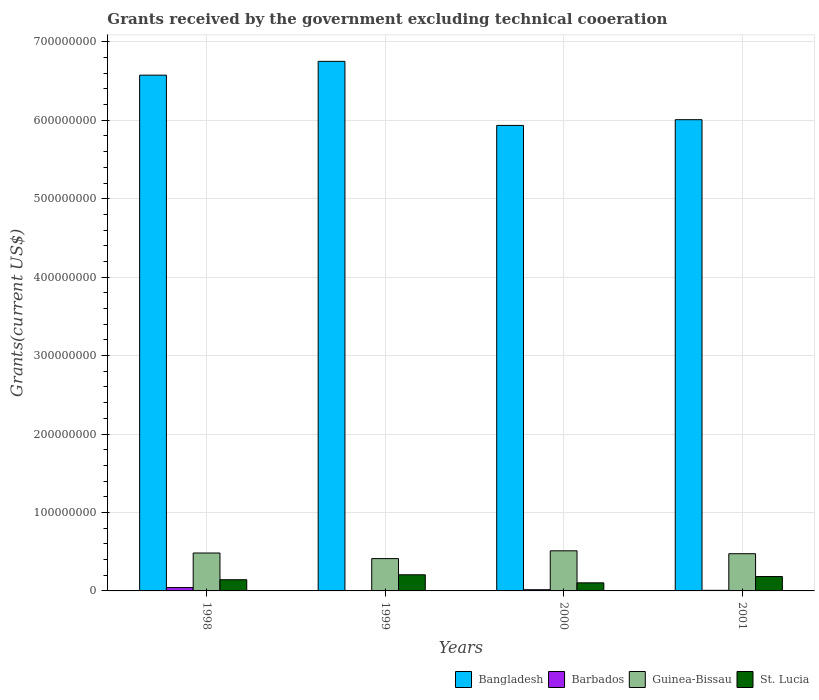How many different coloured bars are there?
Your answer should be compact. 4. Are the number of bars per tick equal to the number of legend labels?
Make the answer very short. Yes. Are the number of bars on each tick of the X-axis equal?
Your answer should be very brief. Yes. In how many cases, is the number of bars for a given year not equal to the number of legend labels?
Offer a very short reply. 0. What is the total grants received by the government in St. Lucia in 2001?
Keep it short and to the point. 1.83e+07. Across all years, what is the maximum total grants received by the government in Bangladesh?
Offer a very short reply. 6.75e+08. Across all years, what is the minimum total grants received by the government in Guinea-Bissau?
Provide a succinct answer. 4.12e+07. What is the total total grants received by the government in Barbados in the graph?
Offer a terse response. 6.74e+06. What is the difference between the total grants received by the government in Bangladesh in 1998 and that in 1999?
Keep it short and to the point. -1.76e+07. What is the difference between the total grants received by the government in Guinea-Bissau in 2000 and the total grants received by the government in Bangladesh in 1998?
Provide a succinct answer. -6.06e+08. What is the average total grants received by the government in St. Lucia per year?
Make the answer very short. 1.59e+07. In the year 2001, what is the difference between the total grants received by the government in St. Lucia and total grants received by the government in Barbados?
Your answer should be very brief. 1.76e+07. What is the ratio of the total grants received by the government in Bangladesh in 2000 to that in 2001?
Your answer should be very brief. 0.99. Is the total grants received by the government in St. Lucia in 2000 less than that in 2001?
Make the answer very short. Yes. Is the difference between the total grants received by the government in St. Lucia in 1998 and 2000 greater than the difference between the total grants received by the government in Barbados in 1998 and 2000?
Provide a succinct answer. Yes. What is the difference between the highest and the second highest total grants received by the government in St. Lucia?
Provide a short and direct response. 2.22e+06. What is the difference between the highest and the lowest total grants received by the government in Bangladesh?
Ensure brevity in your answer.  8.17e+07. In how many years, is the total grants received by the government in St. Lucia greater than the average total grants received by the government in St. Lucia taken over all years?
Your response must be concise. 2. Is the sum of the total grants received by the government in Bangladesh in 1999 and 2001 greater than the maximum total grants received by the government in Barbados across all years?
Your response must be concise. Yes. What does the 3rd bar from the left in 2001 represents?
Keep it short and to the point. Guinea-Bissau. What does the 2nd bar from the right in 2000 represents?
Offer a very short reply. Guinea-Bissau. Are the values on the major ticks of Y-axis written in scientific E-notation?
Provide a short and direct response. No. Does the graph contain grids?
Give a very brief answer. Yes. Where does the legend appear in the graph?
Make the answer very short. Bottom right. How many legend labels are there?
Your answer should be compact. 4. How are the legend labels stacked?
Provide a short and direct response. Horizontal. What is the title of the graph?
Ensure brevity in your answer.  Grants received by the government excluding technical cooeration. Does "Myanmar" appear as one of the legend labels in the graph?
Keep it short and to the point. No. What is the label or title of the Y-axis?
Your answer should be compact. Grants(current US$). What is the Grants(current US$) of Bangladesh in 1998?
Offer a very short reply. 6.58e+08. What is the Grants(current US$) in Barbados in 1998?
Ensure brevity in your answer.  4.30e+06. What is the Grants(current US$) of Guinea-Bissau in 1998?
Keep it short and to the point. 4.83e+07. What is the Grants(current US$) of St. Lucia in 1998?
Offer a very short reply. 1.43e+07. What is the Grants(current US$) of Bangladesh in 1999?
Keep it short and to the point. 6.75e+08. What is the Grants(current US$) of Barbados in 1999?
Your response must be concise. 1.70e+05. What is the Grants(current US$) of Guinea-Bissau in 1999?
Keep it short and to the point. 4.12e+07. What is the Grants(current US$) of St. Lucia in 1999?
Give a very brief answer. 2.06e+07. What is the Grants(current US$) in Bangladesh in 2000?
Ensure brevity in your answer.  5.93e+08. What is the Grants(current US$) in Barbados in 2000?
Offer a terse response. 1.53e+06. What is the Grants(current US$) of Guinea-Bissau in 2000?
Keep it short and to the point. 5.12e+07. What is the Grants(current US$) of St. Lucia in 2000?
Give a very brief answer. 1.03e+07. What is the Grants(current US$) of Bangladesh in 2001?
Provide a succinct answer. 6.01e+08. What is the Grants(current US$) in Barbados in 2001?
Ensure brevity in your answer.  7.40e+05. What is the Grants(current US$) of Guinea-Bissau in 2001?
Give a very brief answer. 4.74e+07. What is the Grants(current US$) in St. Lucia in 2001?
Give a very brief answer. 1.83e+07. Across all years, what is the maximum Grants(current US$) in Bangladesh?
Your answer should be very brief. 6.75e+08. Across all years, what is the maximum Grants(current US$) in Barbados?
Your answer should be very brief. 4.30e+06. Across all years, what is the maximum Grants(current US$) in Guinea-Bissau?
Give a very brief answer. 5.12e+07. Across all years, what is the maximum Grants(current US$) in St. Lucia?
Your response must be concise. 2.06e+07. Across all years, what is the minimum Grants(current US$) of Bangladesh?
Your answer should be very brief. 5.93e+08. Across all years, what is the minimum Grants(current US$) of Barbados?
Your response must be concise. 1.70e+05. Across all years, what is the minimum Grants(current US$) of Guinea-Bissau?
Your answer should be compact. 4.12e+07. Across all years, what is the minimum Grants(current US$) in St. Lucia?
Offer a terse response. 1.03e+07. What is the total Grants(current US$) in Bangladesh in the graph?
Your answer should be very brief. 2.53e+09. What is the total Grants(current US$) in Barbados in the graph?
Your response must be concise. 6.74e+06. What is the total Grants(current US$) in Guinea-Bissau in the graph?
Give a very brief answer. 1.88e+08. What is the total Grants(current US$) of St. Lucia in the graph?
Your answer should be very brief. 6.35e+07. What is the difference between the Grants(current US$) of Bangladesh in 1998 and that in 1999?
Make the answer very short. -1.76e+07. What is the difference between the Grants(current US$) of Barbados in 1998 and that in 1999?
Provide a succinct answer. 4.13e+06. What is the difference between the Grants(current US$) of Guinea-Bissau in 1998 and that in 1999?
Your answer should be very brief. 7.12e+06. What is the difference between the Grants(current US$) in St. Lucia in 1998 and that in 1999?
Provide a succinct answer. -6.30e+06. What is the difference between the Grants(current US$) of Bangladesh in 1998 and that in 2000?
Give a very brief answer. 6.41e+07. What is the difference between the Grants(current US$) in Barbados in 1998 and that in 2000?
Ensure brevity in your answer.  2.77e+06. What is the difference between the Grants(current US$) in Guinea-Bissau in 1998 and that in 2000?
Your answer should be compact. -2.82e+06. What is the difference between the Grants(current US$) in St. Lucia in 1998 and that in 2000?
Your answer should be compact. 3.96e+06. What is the difference between the Grants(current US$) in Bangladesh in 1998 and that in 2001?
Keep it short and to the point. 5.68e+07. What is the difference between the Grants(current US$) of Barbados in 1998 and that in 2001?
Offer a terse response. 3.56e+06. What is the difference between the Grants(current US$) of Guinea-Bissau in 1998 and that in 2001?
Provide a succinct answer. 8.90e+05. What is the difference between the Grants(current US$) in St. Lucia in 1998 and that in 2001?
Your response must be concise. -4.08e+06. What is the difference between the Grants(current US$) in Bangladesh in 1999 and that in 2000?
Give a very brief answer. 8.17e+07. What is the difference between the Grants(current US$) of Barbados in 1999 and that in 2000?
Give a very brief answer. -1.36e+06. What is the difference between the Grants(current US$) of Guinea-Bissau in 1999 and that in 2000?
Your response must be concise. -9.94e+06. What is the difference between the Grants(current US$) in St. Lucia in 1999 and that in 2000?
Offer a very short reply. 1.03e+07. What is the difference between the Grants(current US$) in Bangladesh in 1999 and that in 2001?
Your response must be concise. 7.44e+07. What is the difference between the Grants(current US$) in Barbados in 1999 and that in 2001?
Make the answer very short. -5.70e+05. What is the difference between the Grants(current US$) of Guinea-Bissau in 1999 and that in 2001?
Offer a terse response. -6.23e+06. What is the difference between the Grants(current US$) of St. Lucia in 1999 and that in 2001?
Offer a terse response. 2.22e+06. What is the difference between the Grants(current US$) of Bangladesh in 2000 and that in 2001?
Make the answer very short. -7.28e+06. What is the difference between the Grants(current US$) in Barbados in 2000 and that in 2001?
Your response must be concise. 7.90e+05. What is the difference between the Grants(current US$) of Guinea-Bissau in 2000 and that in 2001?
Your answer should be very brief. 3.71e+06. What is the difference between the Grants(current US$) of St. Lucia in 2000 and that in 2001?
Keep it short and to the point. -8.04e+06. What is the difference between the Grants(current US$) in Bangladesh in 1998 and the Grants(current US$) in Barbados in 1999?
Ensure brevity in your answer.  6.57e+08. What is the difference between the Grants(current US$) in Bangladesh in 1998 and the Grants(current US$) in Guinea-Bissau in 1999?
Keep it short and to the point. 6.16e+08. What is the difference between the Grants(current US$) in Bangladesh in 1998 and the Grants(current US$) in St. Lucia in 1999?
Provide a succinct answer. 6.37e+08. What is the difference between the Grants(current US$) of Barbados in 1998 and the Grants(current US$) of Guinea-Bissau in 1999?
Provide a succinct answer. -3.69e+07. What is the difference between the Grants(current US$) of Barbados in 1998 and the Grants(current US$) of St. Lucia in 1999?
Make the answer very short. -1.63e+07. What is the difference between the Grants(current US$) in Guinea-Bissau in 1998 and the Grants(current US$) in St. Lucia in 1999?
Keep it short and to the point. 2.78e+07. What is the difference between the Grants(current US$) of Bangladesh in 1998 and the Grants(current US$) of Barbados in 2000?
Your answer should be very brief. 6.56e+08. What is the difference between the Grants(current US$) of Bangladesh in 1998 and the Grants(current US$) of Guinea-Bissau in 2000?
Provide a succinct answer. 6.06e+08. What is the difference between the Grants(current US$) of Bangladesh in 1998 and the Grants(current US$) of St. Lucia in 2000?
Keep it short and to the point. 6.47e+08. What is the difference between the Grants(current US$) in Barbados in 1998 and the Grants(current US$) in Guinea-Bissau in 2000?
Offer a terse response. -4.68e+07. What is the difference between the Grants(current US$) in Barbados in 1998 and the Grants(current US$) in St. Lucia in 2000?
Your answer should be compact. -6.00e+06. What is the difference between the Grants(current US$) in Guinea-Bissau in 1998 and the Grants(current US$) in St. Lucia in 2000?
Your answer should be compact. 3.80e+07. What is the difference between the Grants(current US$) of Bangladesh in 1998 and the Grants(current US$) of Barbados in 2001?
Provide a succinct answer. 6.57e+08. What is the difference between the Grants(current US$) of Bangladesh in 1998 and the Grants(current US$) of Guinea-Bissau in 2001?
Offer a terse response. 6.10e+08. What is the difference between the Grants(current US$) of Bangladesh in 1998 and the Grants(current US$) of St. Lucia in 2001?
Make the answer very short. 6.39e+08. What is the difference between the Grants(current US$) in Barbados in 1998 and the Grants(current US$) in Guinea-Bissau in 2001?
Keep it short and to the point. -4.31e+07. What is the difference between the Grants(current US$) of Barbados in 1998 and the Grants(current US$) of St. Lucia in 2001?
Provide a short and direct response. -1.40e+07. What is the difference between the Grants(current US$) of Guinea-Bissau in 1998 and the Grants(current US$) of St. Lucia in 2001?
Your answer should be very brief. 3.00e+07. What is the difference between the Grants(current US$) in Bangladesh in 1999 and the Grants(current US$) in Barbados in 2000?
Offer a terse response. 6.74e+08. What is the difference between the Grants(current US$) in Bangladesh in 1999 and the Grants(current US$) in Guinea-Bissau in 2000?
Offer a very short reply. 6.24e+08. What is the difference between the Grants(current US$) of Bangladesh in 1999 and the Grants(current US$) of St. Lucia in 2000?
Offer a very short reply. 6.65e+08. What is the difference between the Grants(current US$) in Barbados in 1999 and the Grants(current US$) in Guinea-Bissau in 2000?
Your answer should be compact. -5.10e+07. What is the difference between the Grants(current US$) of Barbados in 1999 and the Grants(current US$) of St. Lucia in 2000?
Your answer should be compact. -1.01e+07. What is the difference between the Grants(current US$) in Guinea-Bissau in 1999 and the Grants(current US$) in St. Lucia in 2000?
Offer a terse response. 3.09e+07. What is the difference between the Grants(current US$) of Bangladesh in 1999 and the Grants(current US$) of Barbados in 2001?
Offer a very short reply. 6.74e+08. What is the difference between the Grants(current US$) in Bangladesh in 1999 and the Grants(current US$) in Guinea-Bissau in 2001?
Your response must be concise. 6.28e+08. What is the difference between the Grants(current US$) of Bangladesh in 1999 and the Grants(current US$) of St. Lucia in 2001?
Make the answer very short. 6.57e+08. What is the difference between the Grants(current US$) in Barbados in 1999 and the Grants(current US$) in Guinea-Bissau in 2001?
Ensure brevity in your answer.  -4.73e+07. What is the difference between the Grants(current US$) in Barbados in 1999 and the Grants(current US$) in St. Lucia in 2001?
Your answer should be very brief. -1.82e+07. What is the difference between the Grants(current US$) of Guinea-Bissau in 1999 and the Grants(current US$) of St. Lucia in 2001?
Ensure brevity in your answer.  2.29e+07. What is the difference between the Grants(current US$) in Bangladesh in 2000 and the Grants(current US$) in Barbados in 2001?
Offer a very short reply. 5.93e+08. What is the difference between the Grants(current US$) of Bangladesh in 2000 and the Grants(current US$) of Guinea-Bissau in 2001?
Provide a short and direct response. 5.46e+08. What is the difference between the Grants(current US$) of Bangladesh in 2000 and the Grants(current US$) of St. Lucia in 2001?
Offer a terse response. 5.75e+08. What is the difference between the Grants(current US$) of Barbados in 2000 and the Grants(current US$) of Guinea-Bissau in 2001?
Your response must be concise. -4.59e+07. What is the difference between the Grants(current US$) in Barbados in 2000 and the Grants(current US$) in St. Lucia in 2001?
Your answer should be compact. -1.68e+07. What is the difference between the Grants(current US$) in Guinea-Bissau in 2000 and the Grants(current US$) in St. Lucia in 2001?
Keep it short and to the point. 3.28e+07. What is the average Grants(current US$) in Bangladesh per year?
Provide a short and direct response. 6.32e+08. What is the average Grants(current US$) in Barbados per year?
Offer a terse response. 1.68e+06. What is the average Grants(current US$) of Guinea-Bissau per year?
Make the answer very short. 4.70e+07. What is the average Grants(current US$) of St. Lucia per year?
Give a very brief answer. 1.59e+07. In the year 1998, what is the difference between the Grants(current US$) of Bangladesh and Grants(current US$) of Barbados?
Your answer should be compact. 6.53e+08. In the year 1998, what is the difference between the Grants(current US$) of Bangladesh and Grants(current US$) of Guinea-Bissau?
Offer a very short reply. 6.09e+08. In the year 1998, what is the difference between the Grants(current US$) of Bangladesh and Grants(current US$) of St. Lucia?
Your answer should be compact. 6.43e+08. In the year 1998, what is the difference between the Grants(current US$) in Barbados and Grants(current US$) in Guinea-Bissau?
Make the answer very short. -4.40e+07. In the year 1998, what is the difference between the Grants(current US$) of Barbados and Grants(current US$) of St. Lucia?
Your response must be concise. -9.96e+06. In the year 1998, what is the difference between the Grants(current US$) of Guinea-Bissau and Grants(current US$) of St. Lucia?
Make the answer very short. 3.41e+07. In the year 1999, what is the difference between the Grants(current US$) of Bangladesh and Grants(current US$) of Barbados?
Offer a very short reply. 6.75e+08. In the year 1999, what is the difference between the Grants(current US$) in Bangladesh and Grants(current US$) in Guinea-Bissau?
Make the answer very short. 6.34e+08. In the year 1999, what is the difference between the Grants(current US$) in Bangladesh and Grants(current US$) in St. Lucia?
Your answer should be very brief. 6.55e+08. In the year 1999, what is the difference between the Grants(current US$) of Barbados and Grants(current US$) of Guinea-Bissau?
Provide a short and direct response. -4.10e+07. In the year 1999, what is the difference between the Grants(current US$) in Barbados and Grants(current US$) in St. Lucia?
Give a very brief answer. -2.04e+07. In the year 1999, what is the difference between the Grants(current US$) in Guinea-Bissau and Grants(current US$) in St. Lucia?
Ensure brevity in your answer.  2.06e+07. In the year 2000, what is the difference between the Grants(current US$) in Bangladesh and Grants(current US$) in Barbados?
Provide a short and direct response. 5.92e+08. In the year 2000, what is the difference between the Grants(current US$) in Bangladesh and Grants(current US$) in Guinea-Bissau?
Your answer should be very brief. 5.42e+08. In the year 2000, what is the difference between the Grants(current US$) in Bangladesh and Grants(current US$) in St. Lucia?
Your answer should be very brief. 5.83e+08. In the year 2000, what is the difference between the Grants(current US$) in Barbados and Grants(current US$) in Guinea-Bissau?
Ensure brevity in your answer.  -4.96e+07. In the year 2000, what is the difference between the Grants(current US$) in Barbados and Grants(current US$) in St. Lucia?
Ensure brevity in your answer.  -8.77e+06. In the year 2000, what is the difference between the Grants(current US$) in Guinea-Bissau and Grants(current US$) in St. Lucia?
Offer a very short reply. 4.08e+07. In the year 2001, what is the difference between the Grants(current US$) in Bangladesh and Grants(current US$) in Barbados?
Keep it short and to the point. 6.00e+08. In the year 2001, what is the difference between the Grants(current US$) in Bangladesh and Grants(current US$) in Guinea-Bissau?
Give a very brief answer. 5.53e+08. In the year 2001, what is the difference between the Grants(current US$) of Bangladesh and Grants(current US$) of St. Lucia?
Offer a very short reply. 5.82e+08. In the year 2001, what is the difference between the Grants(current US$) in Barbados and Grants(current US$) in Guinea-Bissau?
Keep it short and to the point. -4.67e+07. In the year 2001, what is the difference between the Grants(current US$) in Barbados and Grants(current US$) in St. Lucia?
Provide a short and direct response. -1.76e+07. In the year 2001, what is the difference between the Grants(current US$) in Guinea-Bissau and Grants(current US$) in St. Lucia?
Provide a short and direct response. 2.91e+07. What is the ratio of the Grants(current US$) in Bangladesh in 1998 to that in 1999?
Provide a short and direct response. 0.97. What is the ratio of the Grants(current US$) in Barbados in 1998 to that in 1999?
Provide a succinct answer. 25.29. What is the ratio of the Grants(current US$) of Guinea-Bissau in 1998 to that in 1999?
Make the answer very short. 1.17. What is the ratio of the Grants(current US$) of St. Lucia in 1998 to that in 1999?
Give a very brief answer. 0.69. What is the ratio of the Grants(current US$) of Bangladesh in 1998 to that in 2000?
Offer a terse response. 1.11. What is the ratio of the Grants(current US$) of Barbados in 1998 to that in 2000?
Offer a terse response. 2.81. What is the ratio of the Grants(current US$) in Guinea-Bissau in 1998 to that in 2000?
Your answer should be compact. 0.94. What is the ratio of the Grants(current US$) in St. Lucia in 1998 to that in 2000?
Your answer should be very brief. 1.38. What is the ratio of the Grants(current US$) of Bangladesh in 1998 to that in 2001?
Keep it short and to the point. 1.09. What is the ratio of the Grants(current US$) of Barbados in 1998 to that in 2001?
Your answer should be compact. 5.81. What is the ratio of the Grants(current US$) of Guinea-Bissau in 1998 to that in 2001?
Ensure brevity in your answer.  1.02. What is the ratio of the Grants(current US$) in St. Lucia in 1998 to that in 2001?
Your answer should be compact. 0.78. What is the ratio of the Grants(current US$) of Bangladesh in 1999 to that in 2000?
Offer a terse response. 1.14. What is the ratio of the Grants(current US$) in Barbados in 1999 to that in 2000?
Your response must be concise. 0.11. What is the ratio of the Grants(current US$) of Guinea-Bissau in 1999 to that in 2000?
Your answer should be very brief. 0.81. What is the ratio of the Grants(current US$) in St. Lucia in 1999 to that in 2000?
Make the answer very short. 2. What is the ratio of the Grants(current US$) in Bangladesh in 1999 to that in 2001?
Give a very brief answer. 1.12. What is the ratio of the Grants(current US$) of Barbados in 1999 to that in 2001?
Your answer should be compact. 0.23. What is the ratio of the Grants(current US$) in Guinea-Bissau in 1999 to that in 2001?
Make the answer very short. 0.87. What is the ratio of the Grants(current US$) in St. Lucia in 1999 to that in 2001?
Provide a succinct answer. 1.12. What is the ratio of the Grants(current US$) in Bangladesh in 2000 to that in 2001?
Keep it short and to the point. 0.99. What is the ratio of the Grants(current US$) of Barbados in 2000 to that in 2001?
Offer a terse response. 2.07. What is the ratio of the Grants(current US$) in Guinea-Bissau in 2000 to that in 2001?
Offer a very short reply. 1.08. What is the ratio of the Grants(current US$) in St. Lucia in 2000 to that in 2001?
Give a very brief answer. 0.56. What is the difference between the highest and the second highest Grants(current US$) of Bangladesh?
Provide a succinct answer. 1.76e+07. What is the difference between the highest and the second highest Grants(current US$) in Barbados?
Keep it short and to the point. 2.77e+06. What is the difference between the highest and the second highest Grants(current US$) in Guinea-Bissau?
Provide a short and direct response. 2.82e+06. What is the difference between the highest and the second highest Grants(current US$) in St. Lucia?
Your answer should be very brief. 2.22e+06. What is the difference between the highest and the lowest Grants(current US$) of Bangladesh?
Keep it short and to the point. 8.17e+07. What is the difference between the highest and the lowest Grants(current US$) in Barbados?
Keep it short and to the point. 4.13e+06. What is the difference between the highest and the lowest Grants(current US$) of Guinea-Bissau?
Your answer should be very brief. 9.94e+06. What is the difference between the highest and the lowest Grants(current US$) in St. Lucia?
Ensure brevity in your answer.  1.03e+07. 